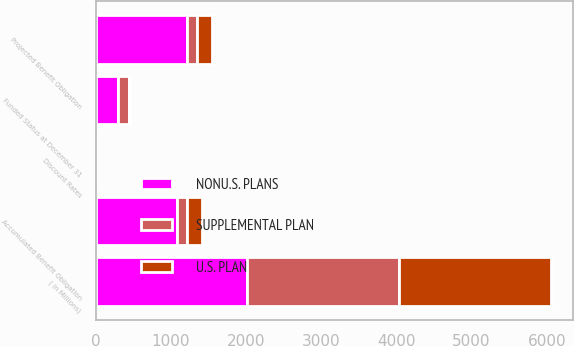<chart> <loc_0><loc_0><loc_500><loc_500><stacked_bar_chart><ecel><fcel>( In Millions)<fcel>Accumulated Benefit Obligation<fcel>Projected Benefit Obligation<fcel>Funded Status at December 31<fcel>Discount Rates<nl><fcel>NONU.S. PLANS<fcel>2017<fcel>1088.4<fcel>1209.9<fcel>296.5<fcel>3.79<nl><fcel>U.S. PLAN<fcel>2017<fcel>192.2<fcel>198.3<fcel>19.6<fcel>2.08<nl><fcel>SUPPLEMENTAL PLAN<fcel>2017<fcel>129<fcel>144.5<fcel>144.5<fcel>3.79<nl></chart> 